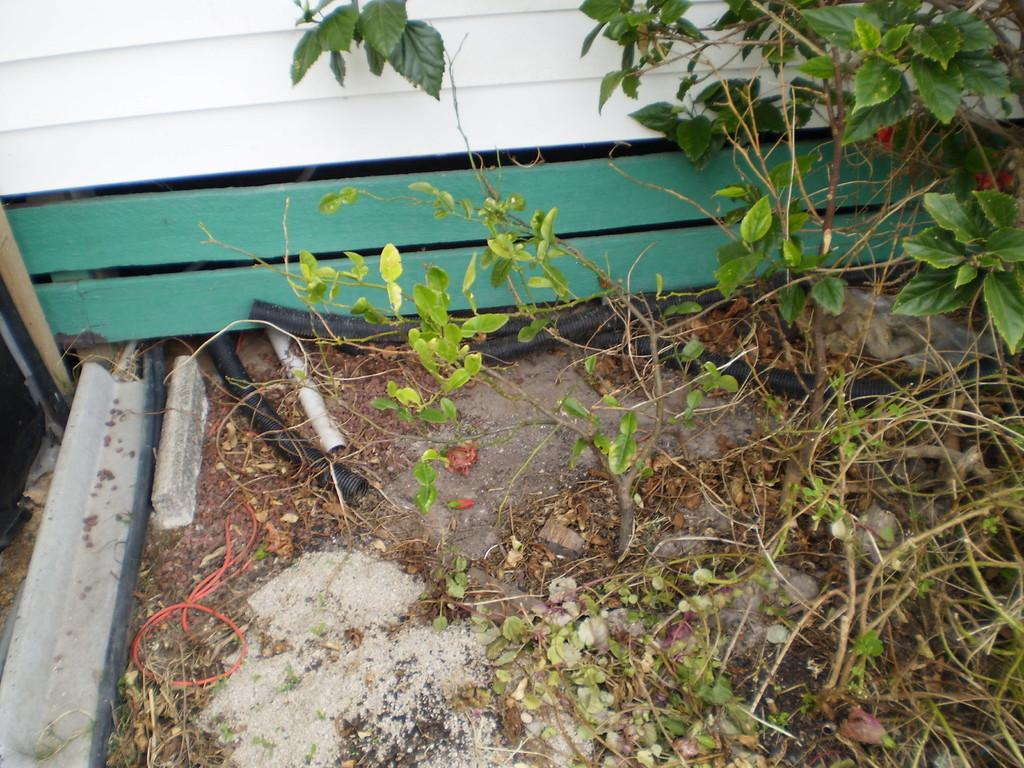What type of living organisms can be seen in the image? Plants can be seen in the image. What else is present on the ground in the image? There are objects placed on the ground in the image. How many chickens are present in the image? There are no chickens present in the image. What type of rock can be seen in the image? There is no rock present in the image. 